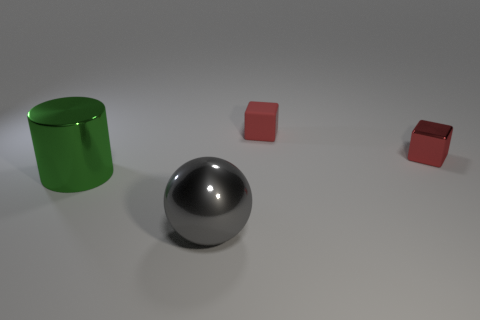Is the material of the green cylinder the same as the ball?
Your answer should be compact. Yes. The object that is in front of the tiny red rubber object and on the right side of the gray sphere is what color?
Provide a succinct answer. Red. What is the shape of the metal object that is the same color as the tiny matte thing?
Offer a very short reply. Cube. What is the size of the shiny object to the right of the large metallic object that is on the right side of the large thing that is behind the big gray metallic thing?
Your answer should be very brief. Small. Do the large green object and the red block that is right of the rubber cube have the same material?
Keep it short and to the point. Yes. Is there any other thing of the same color as the metallic sphere?
Your response must be concise. No. Are there any red shiny cubes in front of the red cube on the left side of the tiny red cube that is in front of the rubber object?
Your response must be concise. Yes. What color is the tiny rubber object?
Provide a succinct answer. Red. There is a tiny rubber block; are there any small red things on the right side of it?
Your response must be concise. Yes. Is the shape of the large green metallic thing the same as the shiny object that is to the right of the sphere?
Your response must be concise. No. 